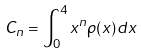<formula> <loc_0><loc_0><loc_500><loc_500>C _ { n } = \int _ { 0 } ^ { 4 } x ^ { n } \rho ( x ) d x</formula> 